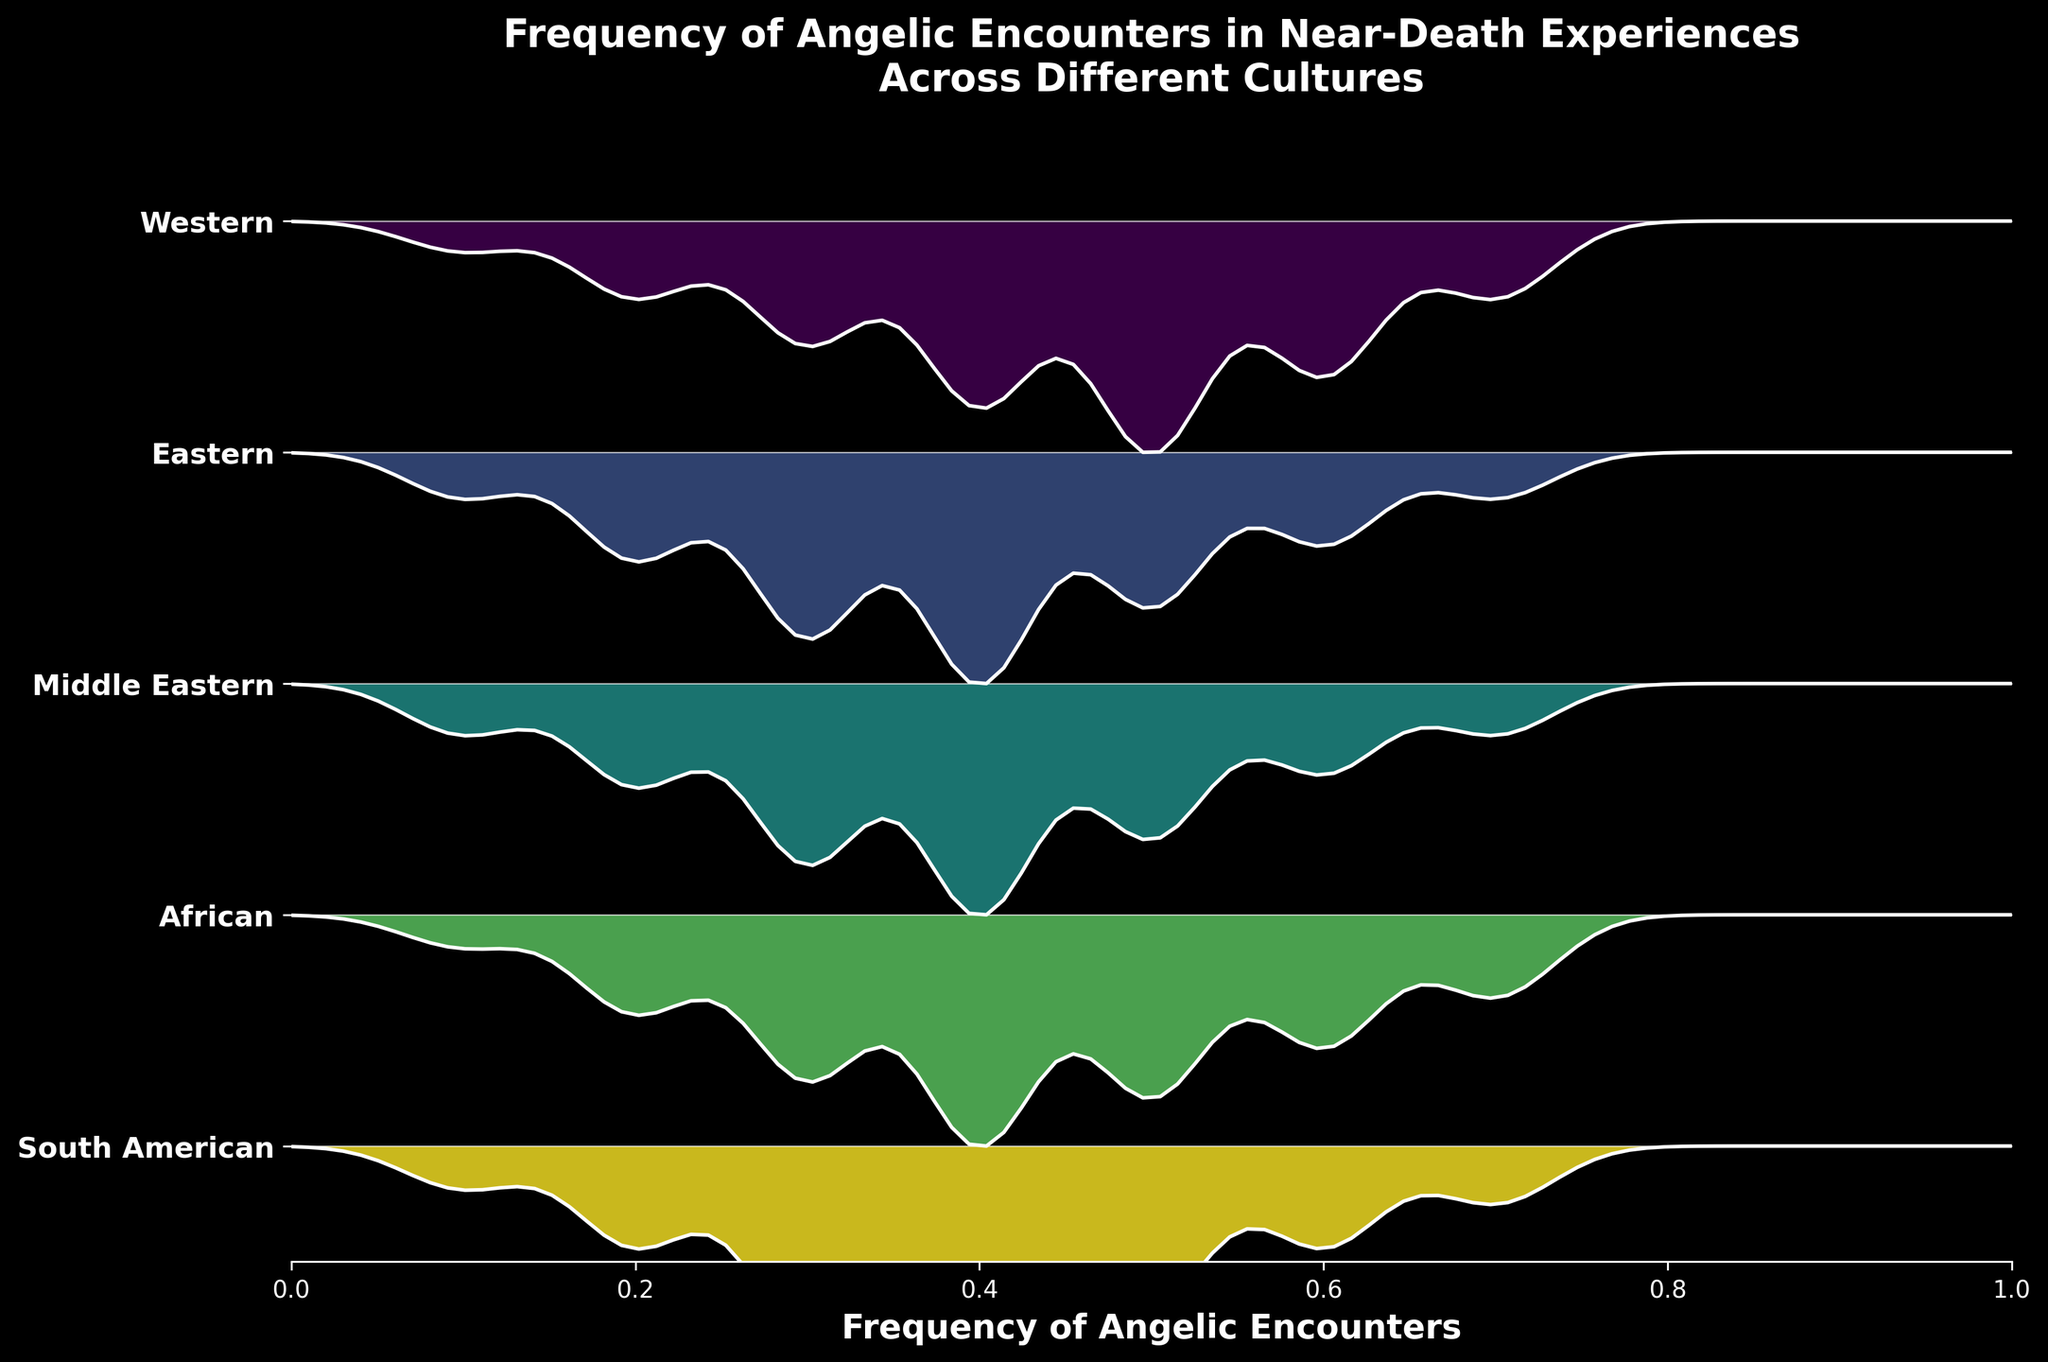what is the title of the figure? The title of the figure is displayed prominently at the top of the plot. It provides a summary of what the figure represents.
Answer: Frequency of Angelic Encounters in Near-Death Experiences Across Different Cultures Which culture shows the highest density of angelic encounters at frequency 0.4? To determine this, look at the plot lines corresponding to different cultures at the 0.4 mark on the x-axis. The culture with the highest peak (density) at this point will be the answer.
Answer: Middle Eastern How many cultures are represented in the figure? Count the number of distinct labels on the y-axis, which correspond to different cultures.
Answer: 5 Which culture has the widest distribution of encounter frequencies? Identify the culture whose plot line spreads most broadly across the x-axis. This indicates a wider range of reported encounter frequencies.
Answer: Middle Eastern In which culture is the peak density of angelic encounters the lowest? Look for the culture whose highest plotted peak is the smallest in height compared to others.
Answer: Western How do the densities of angelic encounters at frequency 0.2 compare between the Western and Eastern cultures? Compare the height of the density plots for Western and Eastern cultures at the 0.2 frequency. The taller peak indicates a higher density.
Answer: Eastern is higher than Western Which culture shows a sharp decline in encounter frequency after 0.5? Look for a culture whose density plot shows a noticeable drop after 0.5 on the x-axis.
Answer: Most cultures show a decline, but Western and Eastern show more gradual declines At what frequency do South American and African cultures have similar densities? Inspect the point along the x-axis where the density curves of South American and African cultures intersect or have very close values.
Answer: Around 0.7 Based on the plot, which culture reports the most consistent density across frequencies? Look for the culture with a relatively smooth and less variable density plot across different frequencies.
Answer: Western What is the range of frequencies spanned by the Middle Eastern culture's density plot? Identify the lowest and highest frequencies (x-values) where the Middle Eastern culture density plot starts and ends.
Answer: 0.1 to 0.7 